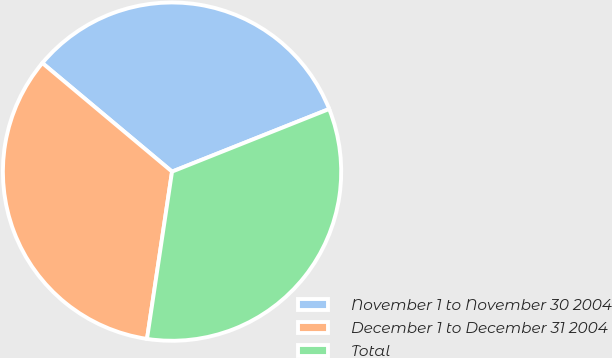Convert chart. <chart><loc_0><loc_0><loc_500><loc_500><pie_chart><fcel>November 1 to November 30 2004<fcel>December 1 to December 31 2004<fcel>Total<nl><fcel>32.87%<fcel>33.73%<fcel>33.4%<nl></chart> 